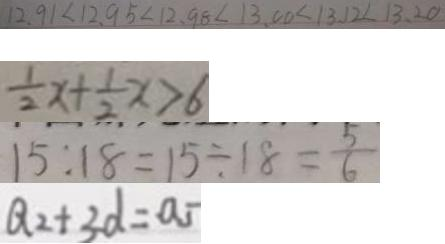Convert formula to latex. <formula><loc_0><loc_0><loc_500><loc_500>1 2 . 9 1 < 1 2 . 9 5 < 1 2 . 9 8 < 1 3 . 0 0 < 1 3 . 1 2 < 1 3 . 2 0 
 \frac { 1 } { 2 } x + \frac { 1 } { 2 } x > 6 
 1 5 : 1 8 = 1 5 \div 1 8 = \frac { 5 } { 6 } 
 Q _ { 2 } + 3 d = a _ { 5 }</formula> 